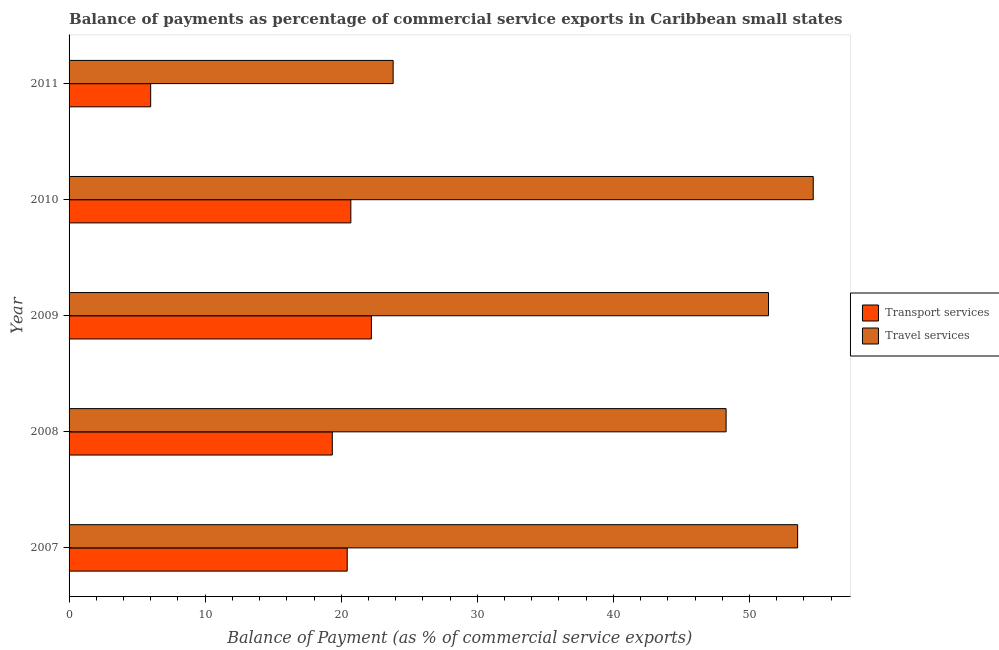How many groups of bars are there?
Your answer should be very brief. 5. Are the number of bars per tick equal to the number of legend labels?
Offer a very short reply. Yes. Are the number of bars on each tick of the Y-axis equal?
Your response must be concise. Yes. What is the balance of payments of travel services in 2009?
Provide a short and direct response. 51.4. Across all years, what is the maximum balance of payments of travel services?
Give a very brief answer. 54.69. Across all years, what is the minimum balance of payments of travel services?
Give a very brief answer. 23.81. In which year was the balance of payments of travel services maximum?
Keep it short and to the point. 2010. What is the total balance of payments of transport services in the graph?
Offer a terse response. 88.7. What is the difference between the balance of payments of transport services in 2008 and that in 2010?
Offer a very short reply. -1.36. What is the difference between the balance of payments of travel services in 2011 and the balance of payments of transport services in 2008?
Keep it short and to the point. 4.47. What is the average balance of payments of travel services per year?
Your answer should be compact. 46.34. In the year 2009, what is the difference between the balance of payments of travel services and balance of payments of transport services?
Your answer should be compact. 29.18. In how many years, is the balance of payments of travel services greater than 6 %?
Your answer should be very brief. 5. What is the ratio of the balance of payments of travel services in 2007 to that in 2010?
Ensure brevity in your answer.  0.98. Is the balance of payments of transport services in 2010 less than that in 2011?
Your answer should be compact. No. Is the difference between the balance of payments of transport services in 2009 and 2011 greater than the difference between the balance of payments of travel services in 2009 and 2011?
Offer a very short reply. No. What is the difference between the highest and the second highest balance of payments of transport services?
Offer a terse response. 1.51. What is the difference between the highest and the lowest balance of payments of travel services?
Offer a very short reply. 30.87. In how many years, is the balance of payments of transport services greater than the average balance of payments of transport services taken over all years?
Give a very brief answer. 4. Is the sum of the balance of payments of travel services in 2007 and 2010 greater than the maximum balance of payments of transport services across all years?
Offer a terse response. Yes. What does the 1st bar from the top in 2011 represents?
Your response must be concise. Travel services. What does the 1st bar from the bottom in 2008 represents?
Provide a short and direct response. Transport services. How many bars are there?
Your answer should be compact. 10. What is the difference between two consecutive major ticks on the X-axis?
Make the answer very short. 10. Are the values on the major ticks of X-axis written in scientific E-notation?
Provide a succinct answer. No. Does the graph contain grids?
Offer a very short reply. No. How many legend labels are there?
Offer a very short reply. 2. What is the title of the graph?
Keep it short and to the point. Balance of payments as percentage of commercial service exports in Caribbean small states. What is the label or title of the X-axis?
Ensure brevity in your answer.  Balance of Payment (as % of commercial service exports). What is the label or title of the Y-axis?
Offer a terse response. Year. What is the Balance of Payment (as % of commercial service exports) of Transport services in 2007?
Offer a terse response. 20.44. What is the Balance of Payment (as % of commercial service exports) of Travel services in 2007?
Offer a very short reply. 53.54. What is the Balance of Payment (as % of commercial service exports) in Transport services in 2008?
Provide a short and direct response. 19.34. What is the Balance of Payment (as % of commercial service exports) of Travel services in 2008?
Give a very brief answer. 48.28. What is the Balance of Payment (as % of commercial service exports) of Transport services in 2009?
Provide a succinct answer. 22.22. What is the Balance of Payment (as % of commercial service exports) of Travel services in 2009?
Your answer should be compact. 51.4. What is the Balance of Payment (as % of commercial service exports) in Transport services in 2010?
Your response must be concise. 20.71. What is the Balance of Payment (as % of commercial service exports) in Travel services in 2010?
Give a very brief answer. 54.69. What is the Balance of Payment (as % of commercial service exports) in Transport services in 2011?
Your answer should be very brief. 6. What is the Balance of Payment (as % of commercial service exports) of Travel services in 2011?
Your answer should be very brief. 23.81. Across all years, what is the maximum Balance of Payment (as % of commercial service exports) of Transport services?
Provide a succinct answer. 22.22. Across all years, what is the maximum Balance of Payment (as % of commercial service exports) of Travel services?
Your answer should be very brief. 54.69. Across all years, what is the minimum Balance of Payment (as % of commercial service exports) of Transport services?
Your response must be concise. 6. Across all years, what is the minimum Balance of Payment (as % of commercial service exports) of Travel services?
Provide a succinct answer. 23.81. What is the total Balance of Payment (as % of commercial service exports) in Transport services in the graph?
Offer a very short reply. 88.7. What is the total Balance of Payment (as % of commercial service exports) of Travel services in the graph?
Offer a terse response. 231.72. What is the difference between the Balance of Payment (as % of commercial service exports) of Transport services in 2007 and that in 2008?
Provide a succinct answer. 1.1. What is the difference between the Balance of Payment (as % of commercial service exports) in Travel services in 2007 and that in 2008?
Ensure brevity in your answer.  5.26. What is the difference between the Balance of Payment (as % of commercial service exports) in Transport services in 2007 and that in 2009?
Ensure brevity in your answer.  -1.78. What is the difference between the Balance of Payment (as % of commercial service exports) of Travel services in 2007 and that in 2009?
Keep it short and to the point. 2.14. What is the difference between the Balance of Payment (as % of commercial service exports) of Transport services in 2007 and that in 2010?
Make the answer very short. -0.27. What is the difference between the Balance of Payment (as % of commercial service exports) in Travel services in 2007 and that in 2010?
Your answer should be compact. -1.15. What is the difference between the Balance of Payment (as % of commercial service exports) in Transport services in 2007 and that in 2011?
Give a very brief answer. 14.44. What is the difference between the Balance of Payment (as % of commercial service exports) of Travel services in 2007 and that in 2011?
Keep it short and to the point. 29.72. What is the difference between the Balance of Payment (as % of commercial service exports) of Transport services in 2008 and that in 2009?
Make the answer very short. -2.87. What is the difference between the Balance of Payment (as % of commercial service exports) of Travel services in 2008 and that in 2009?
Offer a very short reply. -3.12. What is the difference between the Balance of Payment (as % of commercial service exports) of Transport services in 2008 and that in 2010?
Offer a very short reply. -1.36. What is the difference between the Balance of Payment (as % of commercial service exports) of Travel services in 2008 and that in 2010?
Provide a short and direct response. -6.4. What is the difference between the Balance of Payment (as % of commercial service exports) of Transport services in 2008 and that in 2011?
Provide a succinct answer. 13.35. What is the difference between the Balance of Payment (as % of commercial service exports) in Travel services in 2008 and that in 2011?
Give a very brief answer. 24.47. What is the difference between the Balance of Payment (as % of commercial service exports) in Transport services in 2009 and that in 2010?
Give a very brief answer. 1.51. What is the difference between the Balance of Payment (as % of commercial service exports) of Travel services in 2009 and that in 2010?
Your answer should be very brief. -3.29. What is the difference between the Balance of Payment (as % of commercial service exports) in Transport services in 2009 and that in 2011?
Keep it short and to the point. 16.22. What is the difference between the Balance of Payment (as % of commercial service exports) in Travel services in 2009 and that in 2011?
Your answer should be very brief. 27.58. What is the difference between the Balance of Payment (as % of commercial service exports) of Transport services in 2010 and that in 2011?
Give a very brief answer. 14.71. What is the difference between the Balance of Payment (as % of commercial service exports) of Travel services in 2010 and that in 2011?
Make the answer very short. 30.87. What is the difference between the Balance of Payment (as % of commercial service exports) in Transport services in 2007 and the Balance of Payment (as % of commercial service exports) in Travel services in 2008?
Offer a very short reply. -27.84. What is the difference between the Balance of Payment (as % of commercial service exports) of Transport services in 2007 and the Balance of Payment (as % of commercial service exports) of Travel services in 2009?
Provide a succinct answer. -30.96. What is the difference between the Balance of Payment (as % of commercial service exports) of Transport services in 2007 and the Balance of Payment (as % of commercial service exports) of Travel services in 2010?
Make the answer very short. -34.25. What is the difference between the Balance of Payment (as % of commercial service exports) of Transport services in 2007 and the Balance of Payment (as % of commercial service exports) of Travel services in 2011?
Give a very brief answer. -3.38. What is the difference between the Balance of Payment (as % of commercial service exports) in Transport services in 2008 and the Balance of Payment (as % of commercial service exports) in Travel services in 2009?
Offer a very short reply. -32.05. What is the difference between the Balance of Payment (as % of commercial service exports) in Transport services in 2008 and the Balance of Payment (as % of commercial service exports) in Travel services in 2010?
Your answer should be very brief. -35.34. What is the difference between the Balance of Payment (as % of commercial service exports) of Transport services in 2008 and the Balance of Payment (as % of commercial service exports) of Travel services in 2011?
Offer a terse response. -4.47. What is the difference between the Balance of Payment (as % of commercial service exports) of Transport services in 2009 and the Balance of Payment (as % of commercial service exports) of Travel services in 2010?
Make the answer very short. -32.47. What is the difference between the Balance of Payment (as % of commercial service exports) in Transport services in 2009 and the Balance of Payment (as % of commercial service exports) in Travel services in 2011?
Offer a terse response. -1.6. What is the difference between the Balance of Payment (as % of commercial service exports) in Transport services in 2010 and the Balance of Payment (as % of commercial service exports) in Travel services in 2011?
Make the answer very short. -3.11. What is the average Balance of Payment (as % of commercial service exports) of Transport services per year?
Keep it short and to the point. 17.74. What is the average Balance of Payment (as % of commercial service exports) in Travel services per year?
Offer a very short reply. 46.34. In the year 2007, what is the difference between the Balance of Payment (as % of commercial service exports) of Transport services and Balance of Payment (as % of commercial service exports) of Travel services?
Your answer should be very brief. -33.1. In the year 2008, what is the difference between the Balance of Payment (as % of commercial service exports) of Transport services and Balance of Payment (as % of commercial service exports) of Travel services?
Ensure brevity in your answer.  -28.94. In the year 2009, what is the difference between the Balance of Payment (as % of commercial service exports) in Transport services and Balance of Payment (as % of commercial service exports) in Travel services?
Your response must be concise. -29.18. In the year 2010, what is the difference between the Balance of Payment (as % of commercial service exports) of Transport services and Balance of Payment (as % of commercial service exports) of Travel services?
Make the answer very short. -33.98. In the year 2011, what is the difference between the Balance of Payment (as % of commercial service exports) of Transport services and Balance of Payment (as % of commercial service exports) of Travel services?
Ensure brevity in your answer.  -17.82. What is the ratio of the Balance of Payment (as % of commercial service exports) in Transport services in 2007 to that in 2008?
Offer a very short reply. 1.06. What is the ratio of the Balance of Payment (as % of commercial service exports) in Travel services in 2007 to that in 2008?
Ensure brevity in your answer.  1.11. What is the ratio of the Balance of Payment (as % of commercial service exports) in Travel services in 2007 to that in 2009?
Offer a terse response. 1.04. What is the ratio of the Balance of Payment (as % of commercial service exports) in Transport services in 2007 to that in 2010?
Offer a very short reply. 0.99. What is the ratio of the Balance of Payment (as % of commercial service exports) in Transport services in 2007 to that in 2011?
Make the answer very short. 3.41. What is the ratio of the Balance of Payment (as % of commercial service exports) in Travel services in 2007 to that in 2011?
Make the answer very short. 2.25. What is the ratio of the Balance of Payment (as % of commercial service exports) of Transport services in 2008 to that in 2009?
Provide a short and direct response. 0.87. What is the ratio of the Balance of Payment (as % of commercial service exports) of Travel services in 2008 to that in 2009?
Your answer should be compact. 0.94. What is the ratio of the Balance of Payment (as % of commercial service exports) of Transport services in 2008 to that in 2010?
Make the answer very short. 0.93. What is the ratio of the Balance of Payment (as % of commercial service exports) of Travel services in 2008 to that in 2010?
Your response must be concise. 0.88. What is the ratio of the Balance of Payment (as % of commercial service exports) of Transport services in 2008 to that in 2011?
Make the answer very short. 3.23. What is the ratio of the Balance of Payment (as % of commercial service exports) of Travel services in 2008 to that in 2011?
Keep it short and to the point. 2.03. What is the ratio of the Balance of Payment (as % of commercial service exports) of Transport services in 2009 to that in 2010?
Provide a short and direct response. 1.07. What is the ratio of the Balance of Payment (as % of commercial service exports) of Travel services in 2009 to that in 2010?
Give a very brief answer. 0.94. What is the ratio of the Balance of Payment (as % of commercial service exports) of Transport services in 2009 to that in 2011?
Your response must be concise. 3.7. What is the ratio of the Balance of Payment (as % of commercial service exports) of Travel services in 2009 to that in 2011?
Offer a terse response. 2.16. What is the ratio of the Balance of Payment (as % of commercial service exports) in Transport services in 2010 to that in 2011?
Keep it short and to the point. 3.45. What is the ratio of the Balance of Payment (as % of commercial service exports) in Travel services in 2010 to that in 2011?
Give a very brief answer. 2.3. What is the difference between the highest and the second highest Balance of Payment (as % of commercial service exports) of Transport services?
Keep it short and to the point. 1.51. What is the difference between the highest and the second highest Balance of Payment (as % of commercial service exports) in Travel services?
Your answer should be compact. 1.15. What is the difference between the highest and the lowest Balance of Payment (as % of commercial service exports) of Transport services?
Provide a succinct answer. 16.22. What is the difference between the highest and the lowest Balance of Payment (as % of commercial service exports) in Travel services?
Your answer should be compact. 30.87. 